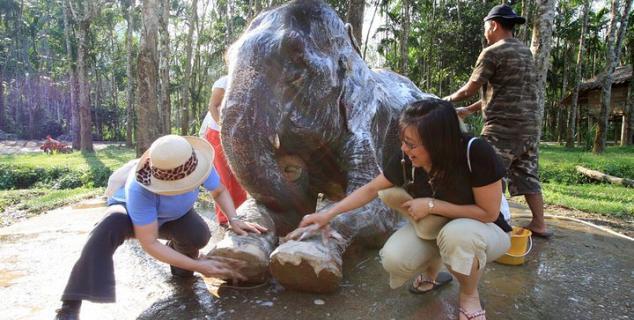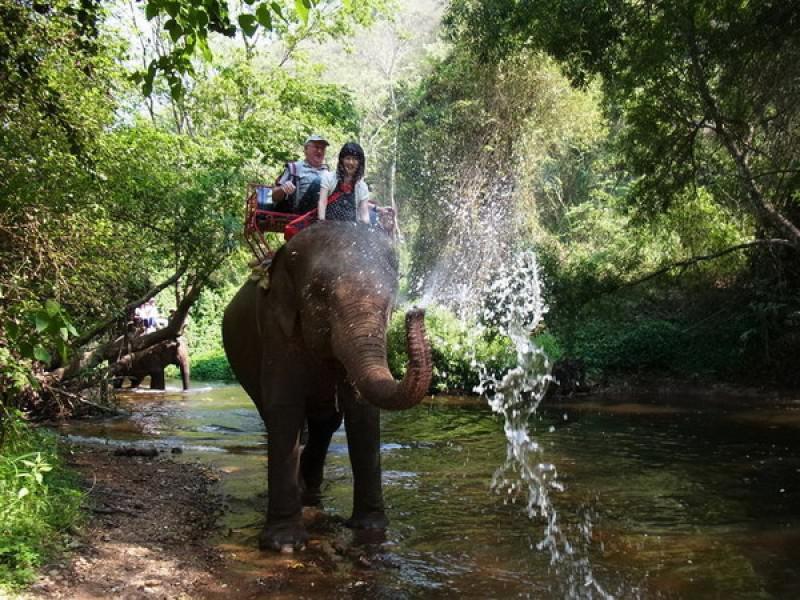The first image is the image on the left, the second image is the image on the right. For the images shown, is this caption "The elephant on the left is being attended to by humans." true? Answer yes or no. Yes. The first image is the image on the left, the second image is the image on the right. For the images shown, is this caption "The left image shows humans interacting with an elephant." true? Answer yes or no. Yes. 